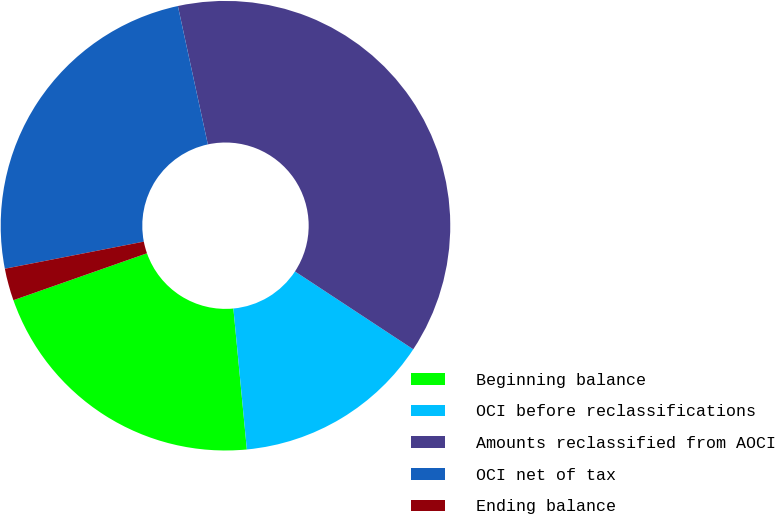Convert chart. <chart><loc_0><loc_0><loc_500><loc_500><pie_chart><fcel>Beginning balance<fcel>OCI before reclassifications<fcel>Amounts reclassified from AOCI<fcel>OCI net of tax<fcel>Ending balance<nl><fcel>21.14%<fcel>14.22%<fcel>37.66%<fcel>24.67%<fcel>2.31%<nl></chart> 